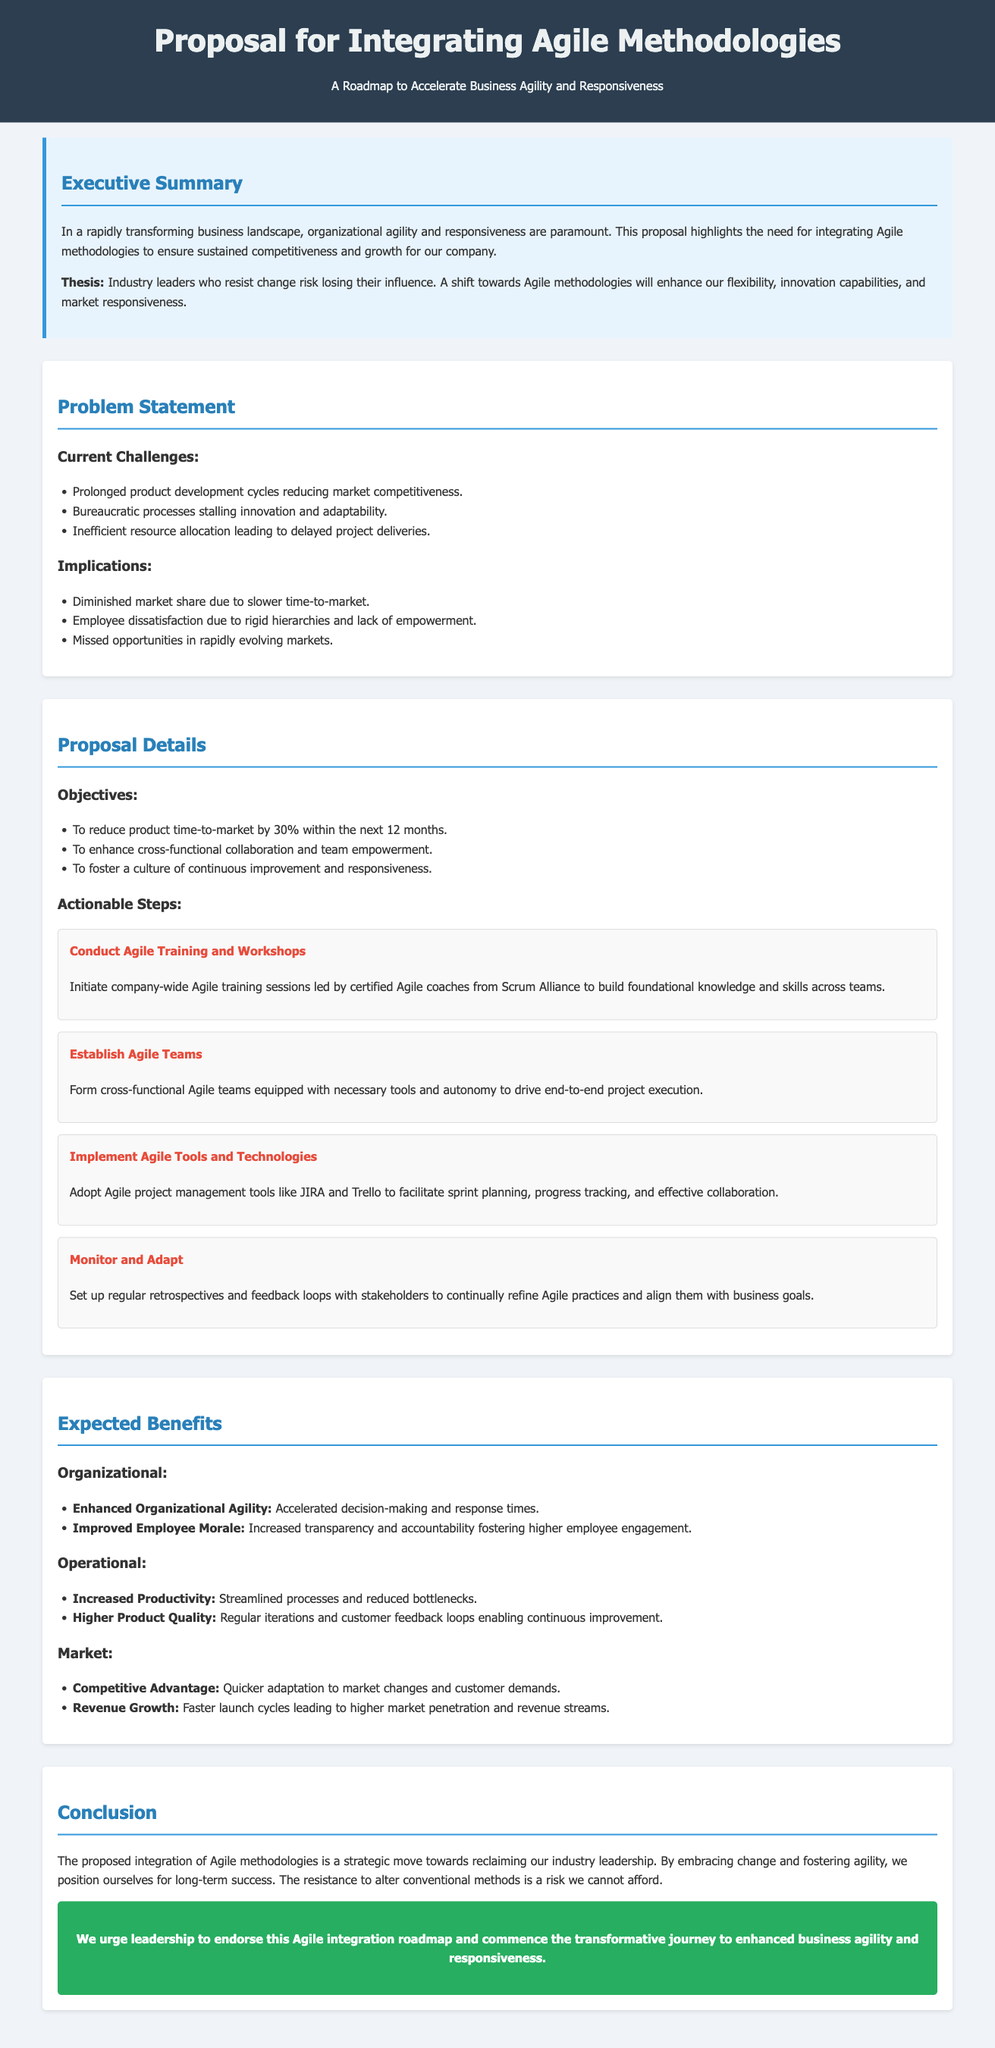What is the thesis of the proposal? The thesis outlines the relationship between resistance to change and industry influence, emphasizing the shift towards Agile for improvement.
Answer: Industry leaders who resist change risk losing their influence What is the target reduction for product time-to-market? The proposal states a specific goal regarding product time-to-market, showing the expected improvement.
Answer: 30% Who will lead the Agile training sessions? The document specifies a group responsible for organizing the training necessary for implementing Agile methodologies.
Answer: Certified Agile coaches from Scrum Alliance What is one implication of current challenges? The proposal lists various implications as a result of the identified challenges, revealing potential consequences for the company.
Answer: Diminished market share due to slower time-to-market What is one expected benefit regarding productivity? The proposal highlights expected operational improvements, specifically within productivity enhancements.
Answer: Increased Productivity What are Agile teams supposed to be equipped with? The document outlines what is necessary for Agile teams to successfully carry out their tasks.
Answer: Necessary tools and autonomy What is a key action step related to Agile tools? The proposal details specific actionable steps, one of which focuses on tools that support Agile processes.
Answer: Implement Agile Tools and Technologies What is the main purpose of conducting regular retrospectives? The document mentions this aspect as a way to identify and implement improvements in Agile practices.
Answer: Continually refine Agile practices and align them with business goals 